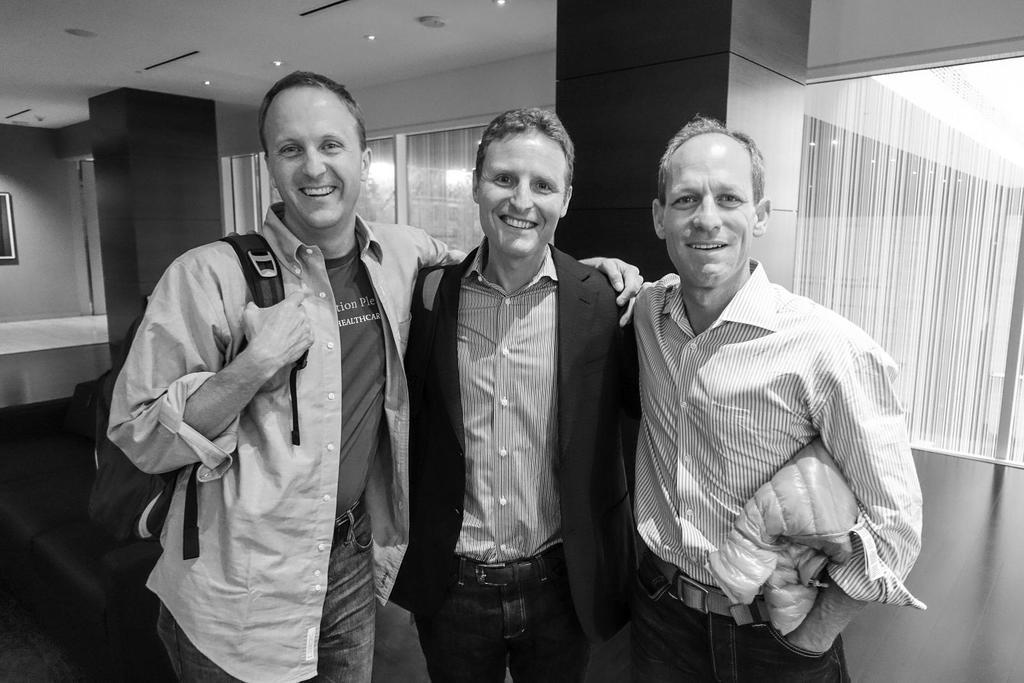How many people are in the image? There are three people standing in the image. What is the facial expression of the people in the image? The people are smiling. What can be seen in the background of the image? There are windows in the background of the image. What type of window treatment is present in the image? Blinds are present on the windows. What is visible at the top of the image? There are lights at the top of the image. What type of furniture is in the image? There is a sofa in the image. What type of wrench is being used by one of the people in the image? There is no wrench present in the image; the people are simply standing and smiling. What flavor of honey can be tasted on the sofa in the image? There is no honey present in the image, and the sofa is not associated with any taste or flavor. 